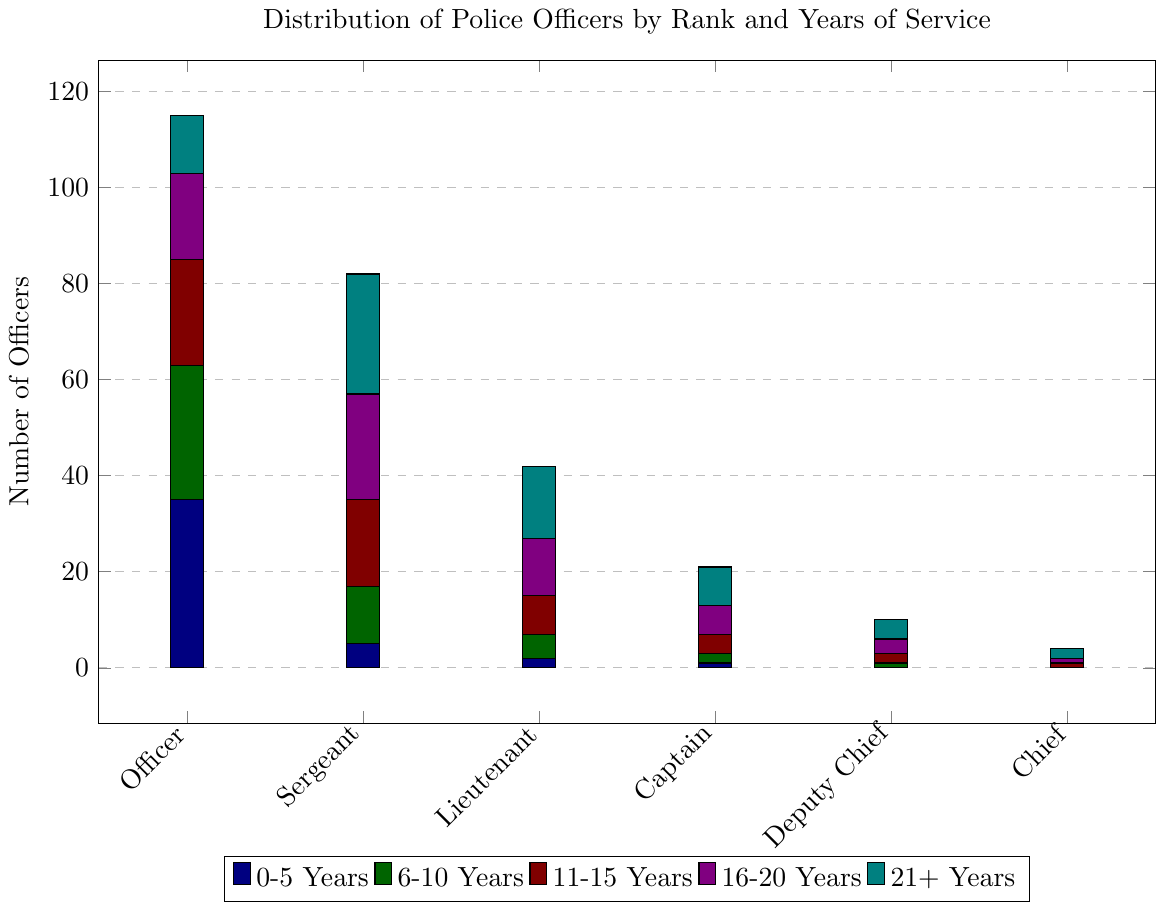What rank has the highest number of officers with 6-10 years of service? Look at the bars representing 6-10 years of service for each rank and find the highest bar. The highest bar is for the sergeants.
Answer: Sergeant Which rank has the fewest officers with 21+ years of service? Identify the smallest bar representing 21+ years of service across all ranks. The smallest bar is for the chief rank.
Answer: Chief How many officers with 16-20 years of service are there in total? Sum the values of officers with 16-20 years of service across all ranks: 18 (Officer) + 22 (Sergeant) + 12 (Lieutenant) + 6 (Captain) + 3 (Deputy Chief) + 1 (Chief) = 62
Answer: 62 Which rank has more officers with 0-5 years of service, sergeant or lieutenant? Compare the bars for 0-5 years of service between the two ranks. The sergeant rank has 5 officers and the lieutenant rank has 2 officers.
Answer: Sergeant What is the total number of officers across all ranks who have 11-15 years of service? Calculate the total by summing up the numbers for 11-15 years of service: 22 (Officer) + 18 (Sergeant) + 8 (Lieutenant) + 4 (Captain) + 2 (Deputy Chief) + 1 (Chief) = 55
Answer: 55 What is the rank distribution of officers with the longest length of service (21+ years)? Look for the bars representing 21+ years of service and note the heights for each rank: 12 (Officer), 25 (Sergeant), 15 (Lieutenant), 8 (Captain), 4 (Deputy Chief), and 2 (Chief).
Answer: Officer: 12, Sergeant: 25, Lieutenant: 15, Captain: 8, Deputy Chief: 4, Chief: 2 For the Captain rank, compare the number of officers between 0-5 years and 21+ years of service. Which is higher? The bar for 0-5 years shows 1 officer and the bar for 21+ years shows 8 officers. 8 is higher than 1.
Answer: 21+ years of service What is the cumulative number of officers classified as Lieutenant or below with 0-5 years of service? Add the values from the 0-5 years category for Officer, Sergeant, and Lieutenant: 35 (Officer) + 5 (Sergeant) + 2 (Lieutenant) = 42
Answer: 42 